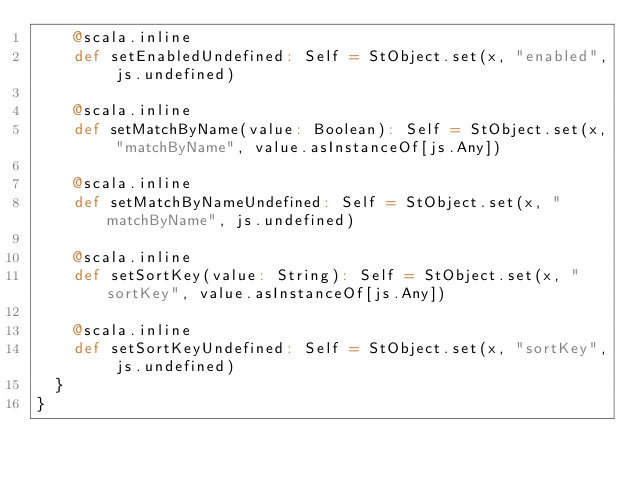Convert code to text. <code><loc_0><loc_0><loc_500><loc_500><_Scala_>    @scala.inline
    def setEnabledUndefined: Self = StObject.set(x, "enabled", js.undefined)
    
    @scala.inline
    def setMatchByName(value: Boolean): Self = StObject.set(x, "matchByName", value.asInstanceOf[js.Any])
    
    @scala.inline
    def setMatchByNameUndefined: Self = StObject.set(x, "matchByName", js.undefined)
    
    @scala.inline
    def setSortKey(value: String): Self = StObject.set(x, "sortKey", value.asInstanceOf[js.Any])
    
    @scala.inline
    def setSortKeyUndefined: Self = StObject.set(x, "sortKey", js.undefined)
  }
}
</code> 